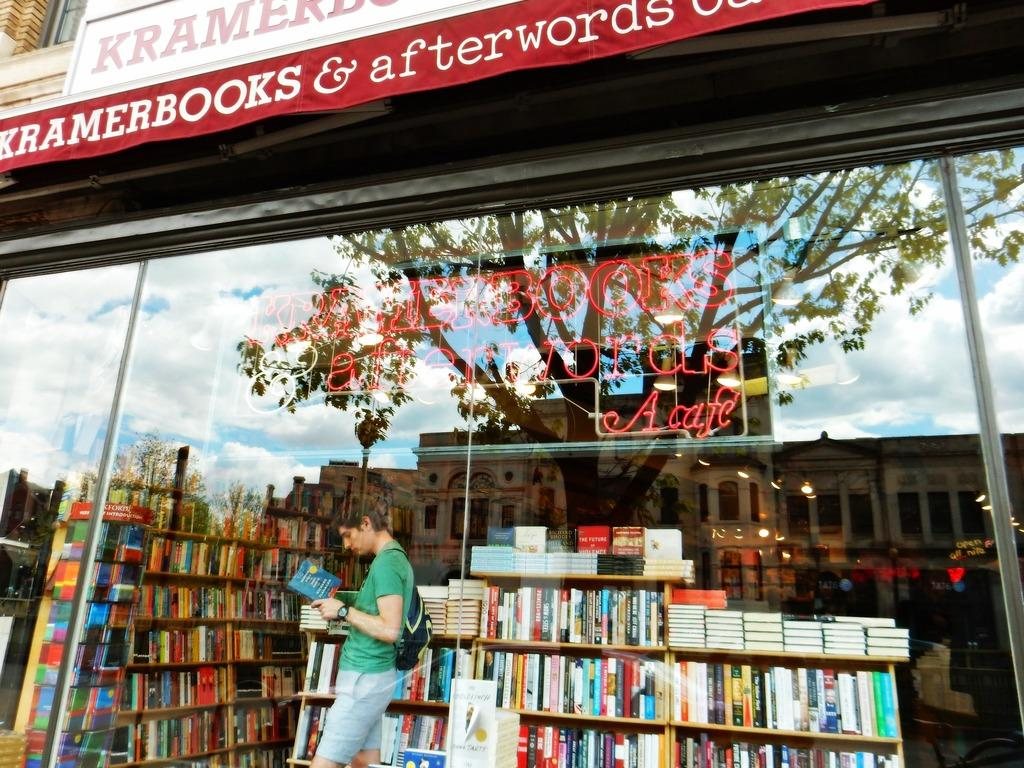<image>
Offer a succinct explanation of the picture presented. A person looks at a book outside of Kramer Books. 